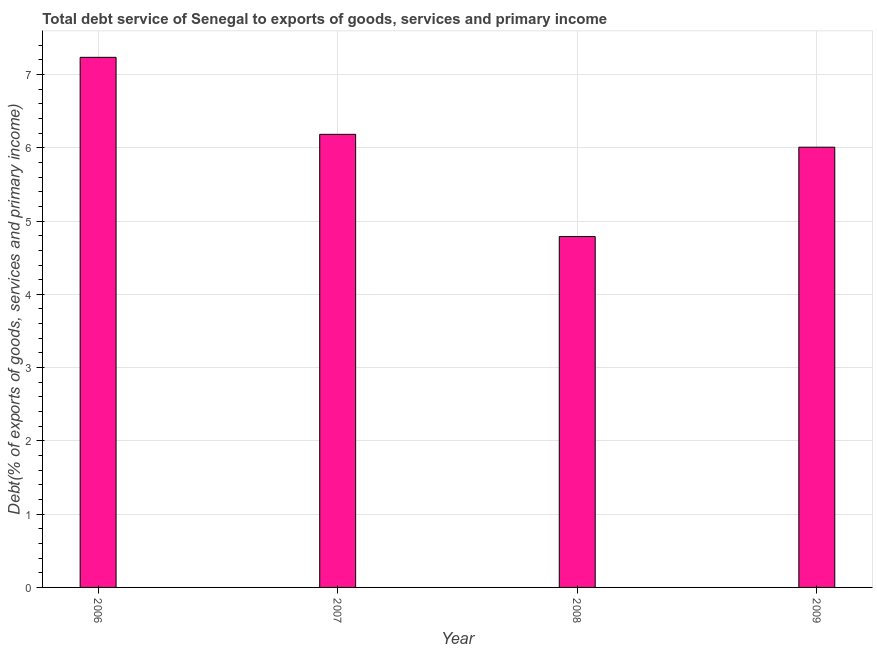Does the graph contain any zero values?
Your answer should be compact. No. Does the graph contain grids?
Give a very brief answer. Yes. What is the title of the graph?
Ensure brevity in your answer.  Total debt service of Senegal to exports of goods, services and primary income. What is the label or title of the X-axis?
Your response must be concise. Year. What is the label or title of the Y-axis?
Offer a very short reply. Debt(% of exports of goods, services and primary income). What is the total debt service in 2008?
Provide a short and direct response. 4.79. Across all years, what is the maximum total debt service?
Ensure brevity in your answer.  7.23. Across all years, what is the minimum total debt service?
Provide a short and direct response. 4.79. In which year was the total debt service maximum?
Offer a very short reply. 2006. What is the sum of the total debt service?
Your answer should be compact. 24.21. What is the difference between the total debt service in 2008 and 2009?
Provide a succinct answer. -1.22. What is the average total debt service per year?
Your answer should be compact. 6.05. What is the median total debt service?
Make the answer very short. 6.1. Do a majority of the years between 2008 and 2009 (inclusive) have total debt service greater than 1.4 %?
Offer a terse response. Yes. What is the ratio of the total debt service in 2006 to that in 2009?
Provide a short and direct response. 1.2. What is the difference between the highest and the second highest total debt service?
Your response must be concise. 1.05. What is the difference between the highest and the lowest total debt service?
Make the answer very short. 2.45. In how many years, is the total debt service greater than the average total debt service taken over all years?
Provide a short and direct response. 2. How many bars are there?
Keep it short and to the point. 4. Are all the bars in the graph horizontal?
Offer a terse response. No. What is the difference between two consecutive major ticks on the Y-axis?
Keep it short and to the point. 1. Are the values on the major ticks of Y-axis written in scientific E-notation?
Make the answer very short. No. What is the Debt(% of exports of goods, services and primary income) of 2006?
Your response must be concise. 7.23. What is the Debt(% of exports of goods, services and primary income) in 2007?
Provide a short and direct response. 6.18. What is the Debt(% of exports of goods, services and primary income) in 2008?
Provide a short and direct response. 4.79. What is the Debt(% of exports of goods, services and primary income) in 2009?
Your answer should be compact. 6.01. What is the difference between the Debt(% of exports of goods, services and primary income) in 2006 and 2007?
Ensure brevity in your answer.  1.05. What is the difference between the Debt(% of exports of goods, services and primary income) in 2006 and 2008?
Offer a very short reply. 2.45. What is the difference between the Debt(% of exports of goods, services and primary income) in 2006 and 2009?
Provide a succinct answer. 1.23. What is the difference between the Debt(% of exports of goods, services and primary income) in 2007 and 2008?
Your answer should be very brief. 1.39. What is the difference between the Debt(% of exports of goods, services and primary income) in 2007 and 2009?
Your answer should be compact. 0.18. What is the difference between the Debt(% of exports of goods, services and primary income) in 2008 and 2009?
Offer a terse response. -1.22. What is the ratio of the Debt(% of exports of goods, services and primary income) in 2006 to that in 2007?
Your answer should be very brief. 1.17. What is the ratio of the Debt(% of exports of goods, services and primary income) in 2006 to that in 2008?
Your answer should be very brief. 1.51. What is the ratio of the Debt(% of exports of goods, services and primary income) in 2006 to that in 2009?
Provide a succinct answer. 1.2. What is the ratio of the Debt(% of exports of goods, services and primary income) in 2007 to that in 2008?
Ensure brevity in your answer.  1.29. What is the ratio of the Debt(% of exports of goods, services and primary income) in 2007 to that in 2009?
Provide a succinct answer. 1.03. What is the ratio of the Debt(% of exports of goods, services and primary income) in 2008 to that in 2009?
Keep it short and to the point. 0.8. 